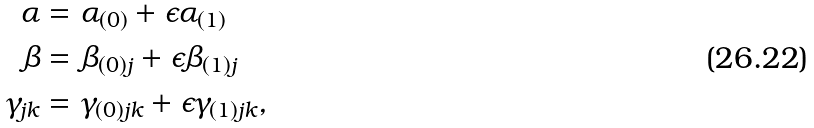Convert formula to latex. <formula><loc_0><loc_0><loc_500><loc_500>\alpha & = \alpha _ { ( 0 ) } + \epsilon \alpha _ { ( 1 ) } \\ \beta & = \beta _ { ( 0 ) j } + \epsilon \beta _ { ( 1 ) j } \\ \gamma _ { j k } & = \gamma _ { ( 0 ) j k } + \epsilon \gamma _ { ( 1 ) j k } ,</formula> 